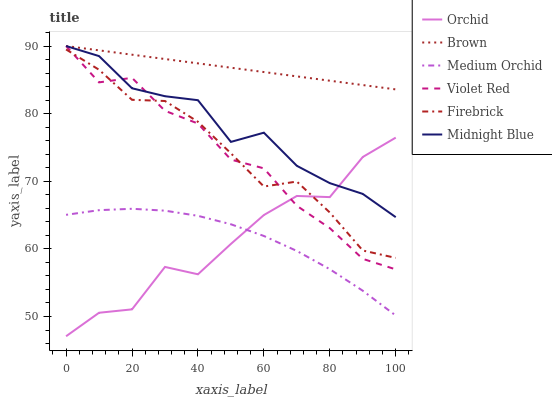Does Orchid have the minimum area under the curve?
Answer yes or no. Yes. Does Brown have the maximum area under the curve?
Answer yes or no. Yes. Does Violet Red have the minimum area under the curve?
Answer yes or no. No. Does Violet Red have the maximum area under the curve?
Answer yes or no. No. Is Brown the smoothest?
Answer yes or no. Yes. Is Orchid the roughest?
Answer yes or no. Yes. Is Violet Red the smoothest?
Answer yes or no. No. Is Violet Red the roughest?
Answer yes or no. No. Does Violet Red have the lowest value?
Answer yes or no. No. Does Firebrick have the highest value?
Answer yes or no. No. Is Medium Orchid less than Firebrick?
Answer yes or no. Yes. Is Midnight Blue greater than Medium Orchid?
Answer yes or no. Yes. Does Medium Orchid intersect Firebrick?
Answer yes or no. No. 